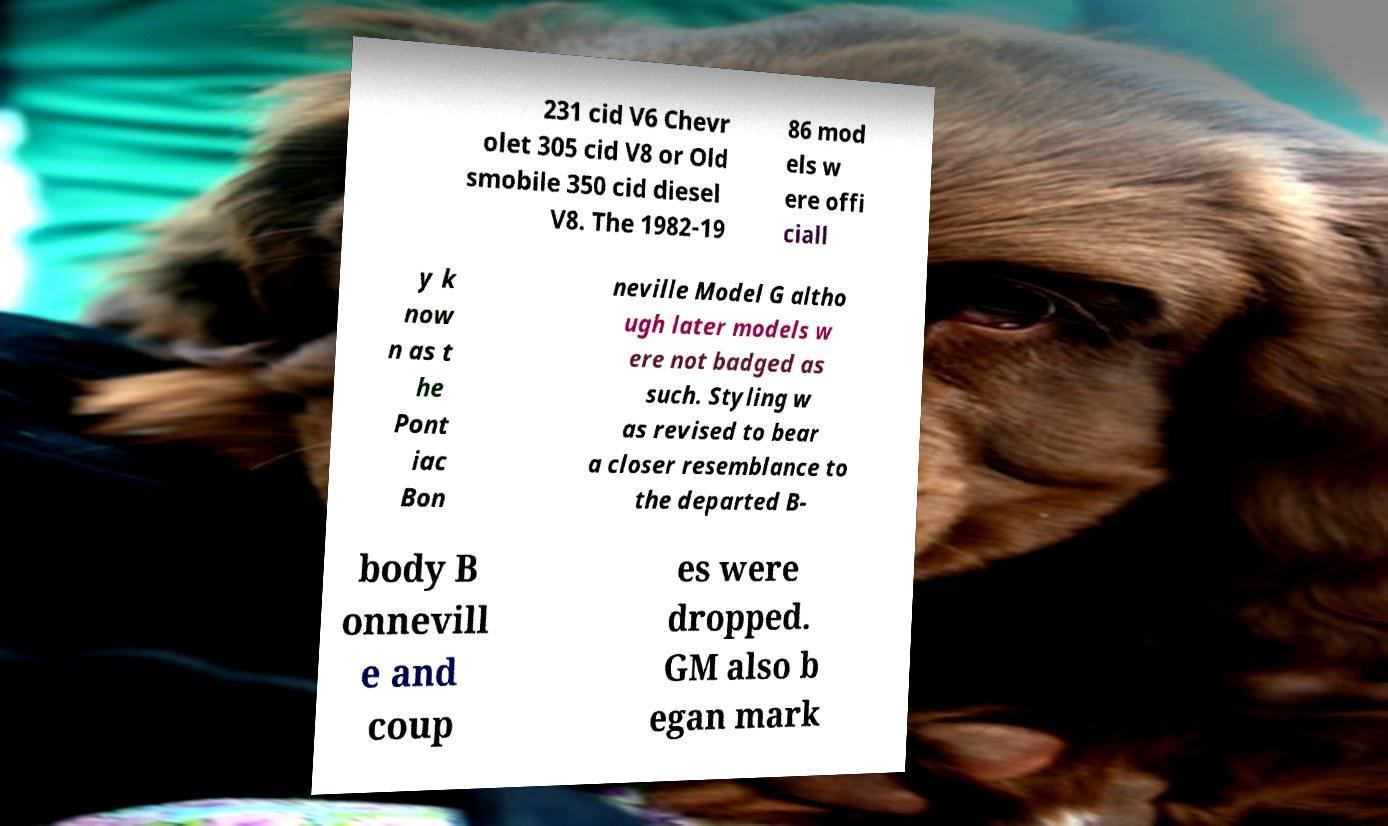Could you extract and type out the text from this image? 231 cid V6 Chevr olet 305 cid V8 or Old smobile 350 cid diesel V8. The 1982-19 86 mod els w ere offi ciall y k now n as t he Pont iac Bon neville Model G altho ugh later models w ere not badged as such. Styling w as revised to bear a closer resemblance to the departed B- body B onnevill e and coup es were dropped. GM also b egan mark 